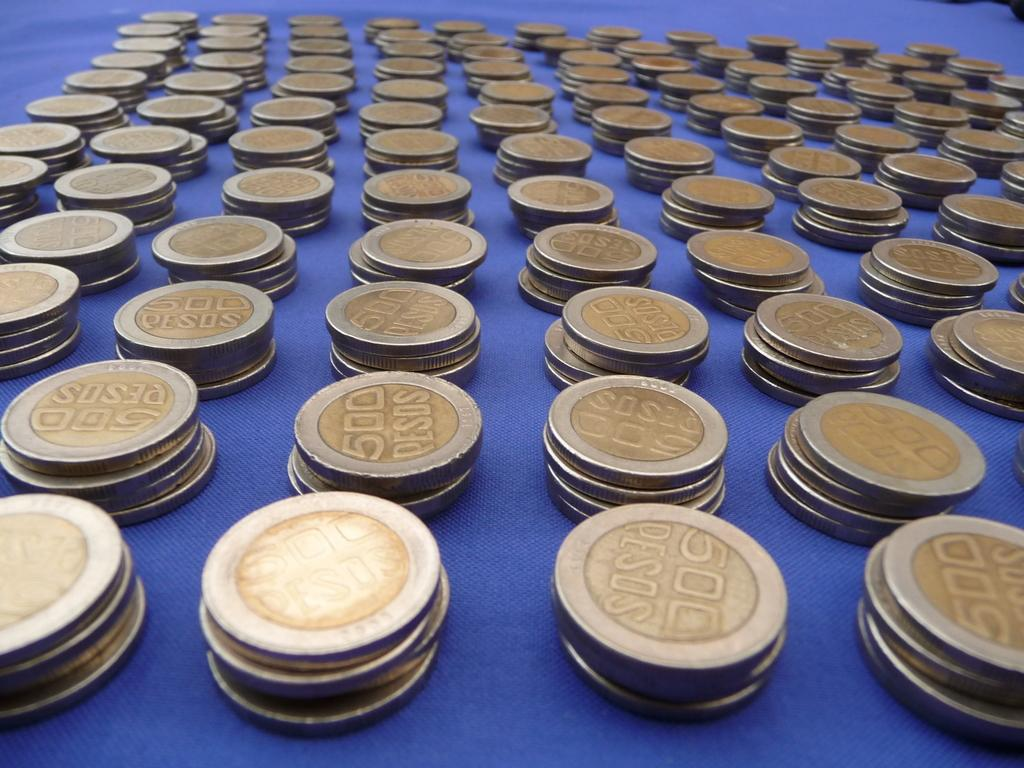<image>
Write a terse but informative summary of the picture. Several stacks of Pesos are lined up on a table. 